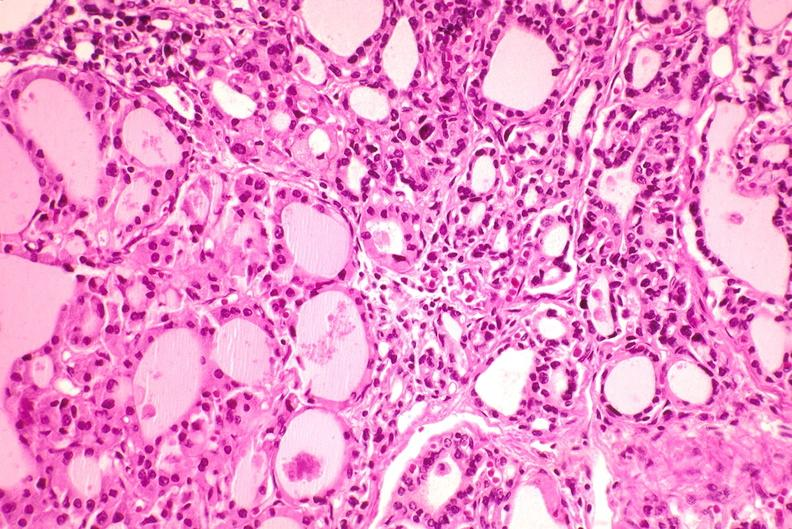what does this image show?
Answer the question using a single word or phrase. Thyroid 